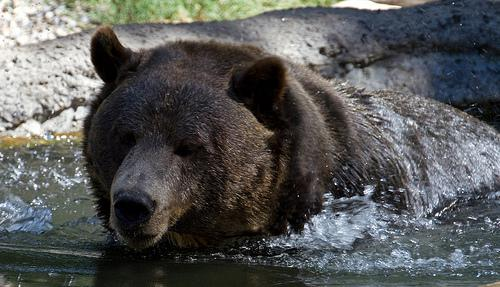Question: where is the bear?
Choices:
A. On the lake.
B. On the island.
C. In the river.
D. At the beach.
Answer with the letter. Answer: C Question: what else is the bear doing?
Choices:
A. Growling.
B. Standing.
C. Splashing around.
D. Eating.
Answer with the letter. Answer: C Question: what is behind the bear?
Choices:
A. Other bears.
B. The zookeeper.
C. Grass and rocks.
D. Fish.
Answer with the letter. Answer: C Question: what is the bear doing?
Choices:
A. Eating.
B. Swimming.
C. Growling.
D. Standing.
Answer with the letter. Answer: B 